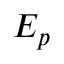Convert formula to latex. <formula><loc_0><loc_0><loc_500><loc_500>E _ { p }</formula> 